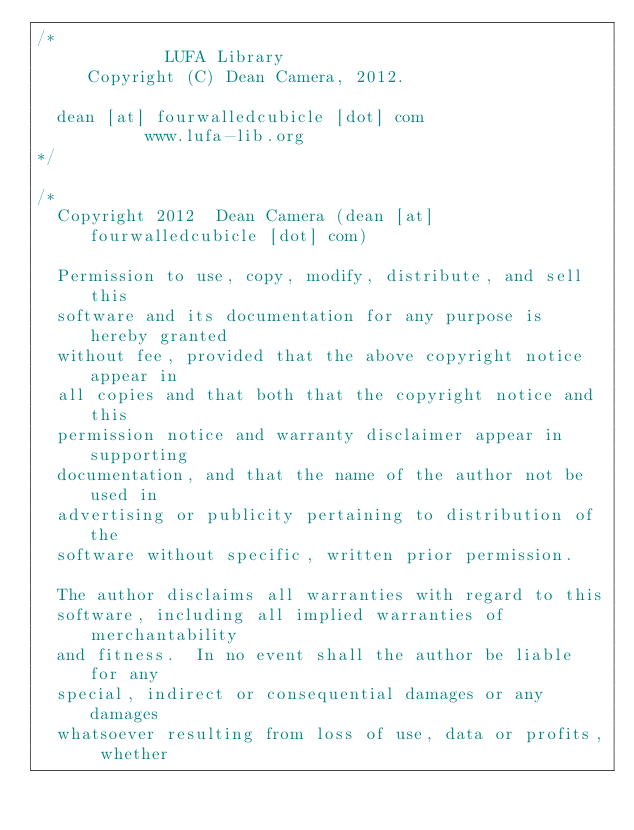<code> <loc_0><loc_0><loc_500><loc_500><_C_>/*
             LUFA Library
     Copyright (C) Dean Camera, 2012.

  dean [at] fourwalledcubicle [dot] com
           www.lufa-lib.org
*/

/*
  Copyright 2012  Dean Camera (dean [at] fourwalledcubicle [dot] com)

  Permission to use, copy, modify, distribute, and sell this
  software and its documentation for any purpose is hereby granted
  without fee, provided that the above copyright notice appear in
  all copies and that both that the copyright notice and this
  permission notice and warranty disclaimer appear in supporting
  documentation, and that the name of the author not be used in
  advertising or publicity pertaining to distribution of the
  software without specific, written prior permission.

  The author disclaims all warranties with regard to this
  software, including all implied warranties of merchantability
  and fitness.  In no event shall the author be liable for any
  special, indirect or consequential damages or any damages
  whatsoever resulting from loss of use, data or profits, whether</code> 